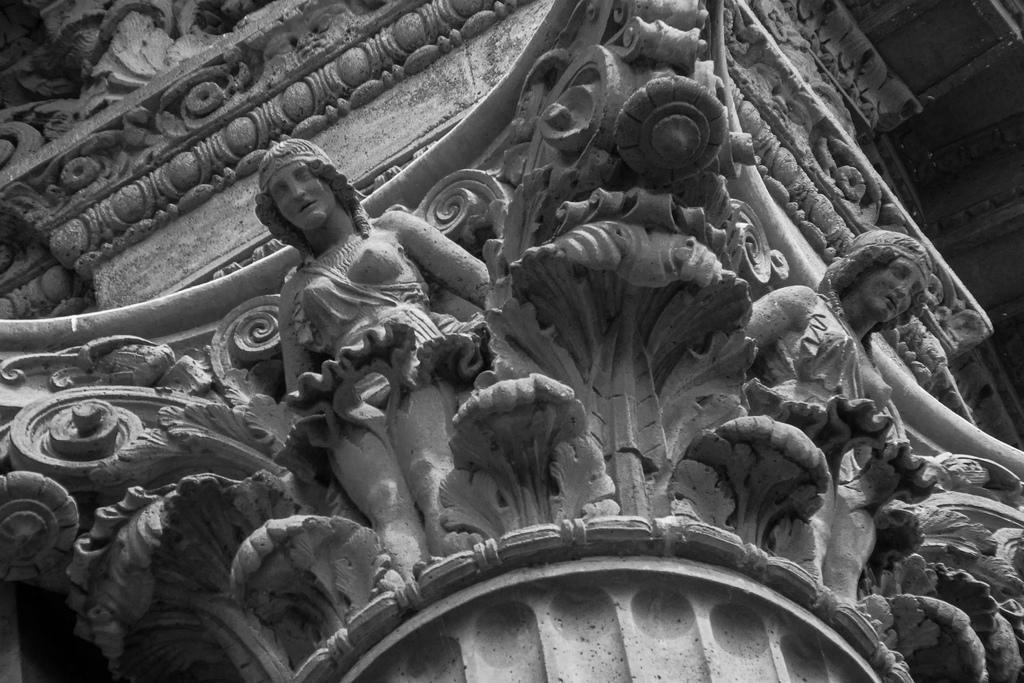Please provide a concise description of this image. In this image I can see sculptures of two persons and a wall. It looks as if the image is taken near the church. 